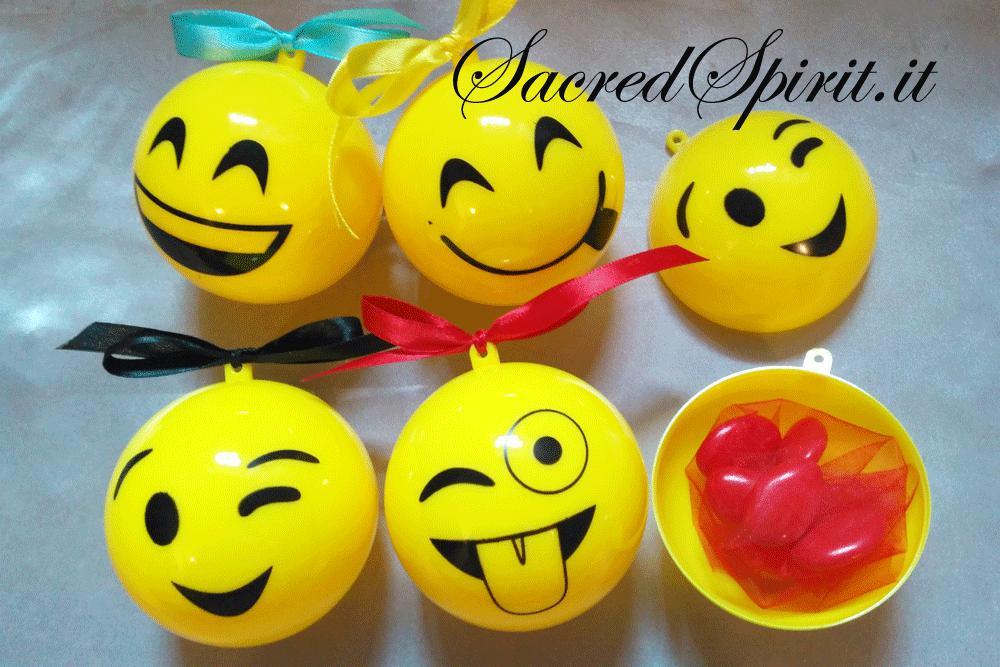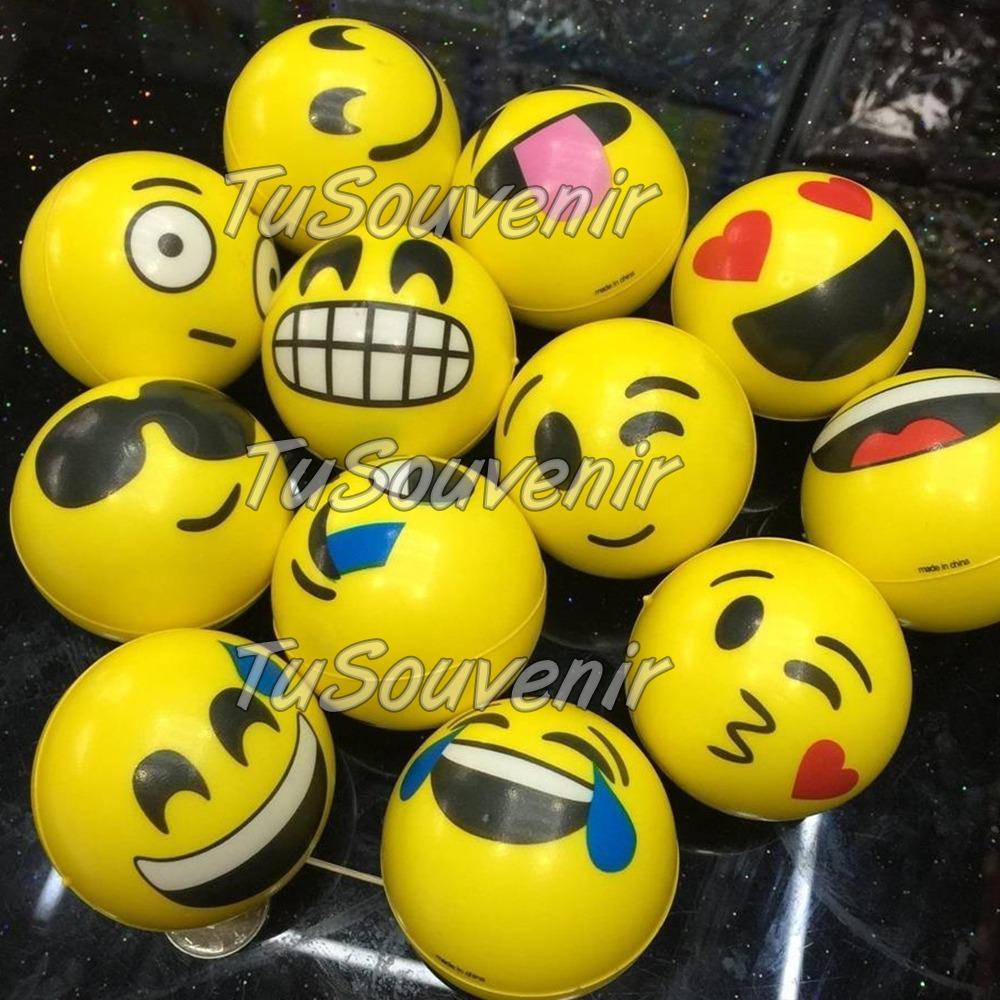The first image is the image on the left, the second image is the image on the right. Evaluate the accuracy of this statement regarding the images: "At least some of the balls are made to look like emojis.". Is it true? Answer yes or no. Yes. The first image is the image on the left, the second image is the image on the right. Analyze the images presented: Is the assertion "There is an open ball with something inside it in the left image, but not in the right." valid? Answer yes or no. Yes. 